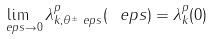<formula> <loc_0><loc_0><loc_500><loc_500>\lim _ { \ e p s \to 0 } \lambda _ { k , \theta ^ { \pm } _ { \ } e p s } ^ { p } ( \ e p s ) = \lambda _ { k } ^ { p } ( 0 )</formula> 